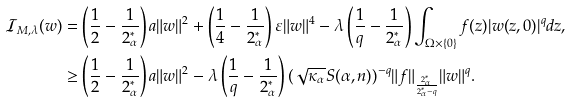Convert formula to latex. <formula><loc_0><loc_0><loc_500><loc_500>\mathcal { I } _ { M , \lambda } ( w ) & = \left ( \frac { 1 } { 2 } - \frac { 1 } { 2 ^ { * } _ { \alpha } } \right ) a \| w \| ^ { 2 } + \left ( \frac { 1 } { 4 } - \frac { 1 } { 2 ^ { * } _ { \alpha } } \right ) \varepsilon \| w \| ^ { 4 } - \lambda \left ( \frac { 1 } { q } - \frac { 1 } { 2 ^ { * } _ { \alpha } } \right ) \int _ { \Omega \times \{ 0 \} } f ( z ) | w ( z , 0 ) | ^ { q } d z , \\ & \geq \left ( \frac { 1 } { 2 } - \frac { 1 } { 2 ^ { * } _ { \alpha } } \right ) a \| w \| ^ { 2 } - \lambda \left ( \frac { 1 } { q } - \frac { 1 } { 2 ^ { * } _ { \alpha } } \right ) ( \sqrt { \kappa _ { \alpha } } S ( \alpha , n ) ) ^ { - q } \| f \| _ { \frac { 2 ^ { * } _ { \alpha } } { { 2 ^ { * } _ { \alpha } } - q } } \| w \| ^ { q } .</formula> 